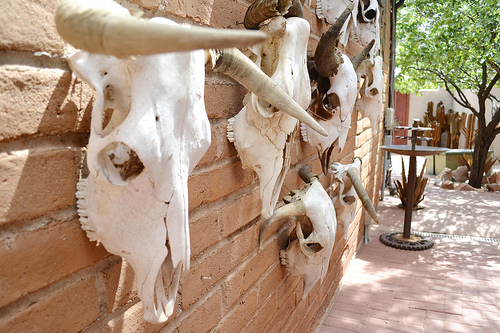<image>
Is there a skeleton on the table? No. The skeleton is not positioned on the table. They may be near each other, but the skeleton is not supported by or resting on top of the table. Where is the skull in relation to the wall? Is it behind the wall? No. The skull is not behind the wall. From this viewpoint, the skull appears to be positioned elsewhere in the scene. 